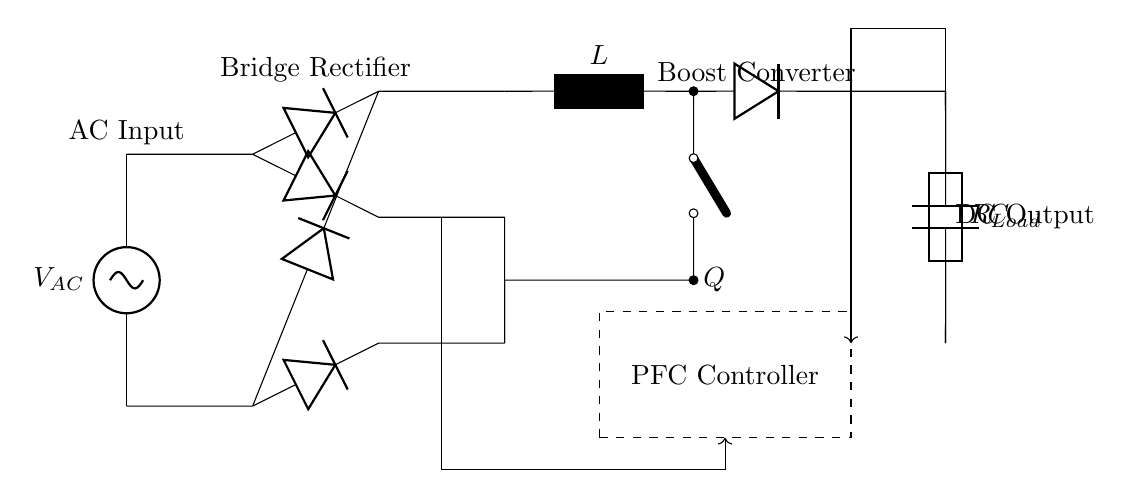What type of circuit is represented here? This circuit is a power factor correction circuit for industrial lighting systems, as indicated by the components and layout designed to optimize the power factor.
Answer: Power factor correction circuit What is the function of the diode in this circuit? The diodes in this circuit form a bridge rectifier, converting alternating current to direct current, allowing the circuit to operate with DC voltage.
Answer: Bridge rectifier What does the inductor labeled L do in the circuit? The inductor in this circuit plays a role in energy storage and control of the current flow during the switching operation of the boost converter.
Answer: Energy storage What is the role of the PFC controller? The PFC controller ensures the circuit maintains optimal power factor by adjusting the operation of the boost converter according to the load requirements.
Answer: Optimal power factor maintenance What is the output voltage type of this circuit? The output voltage type of this circuit is DC, as indicated by the presence of the bridge rectifier and output capacitor configuration for rectification and smoothing.
Answer: DC voltage How does the capacitor labeled C function in this circuit? The capacitor functions to smooth the output voltage by filtering out ripples created during the rectification process, providing a stable DC voltage supply across the load.
Answer: Smooth out voltage What does the load resistor represent in this circuit? The load resistor represents the consumer or application that utilizes the energy produced by the power factor correction circuit, such as lighting fixtures in industrial settings.
Answer: Load consumer 